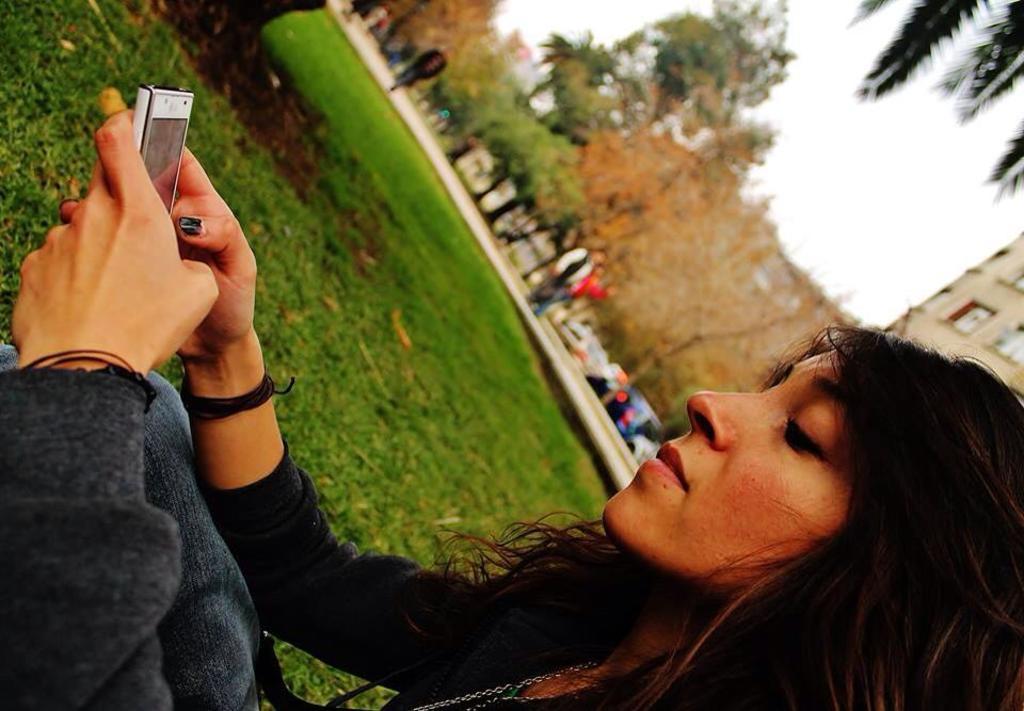In one or two sentences, can you explain what this image depicts? In the foreground of the picture there is a woman holding a mobile. In the center there is grass. In the background of the picture there are trees, people, vehicles and building. 